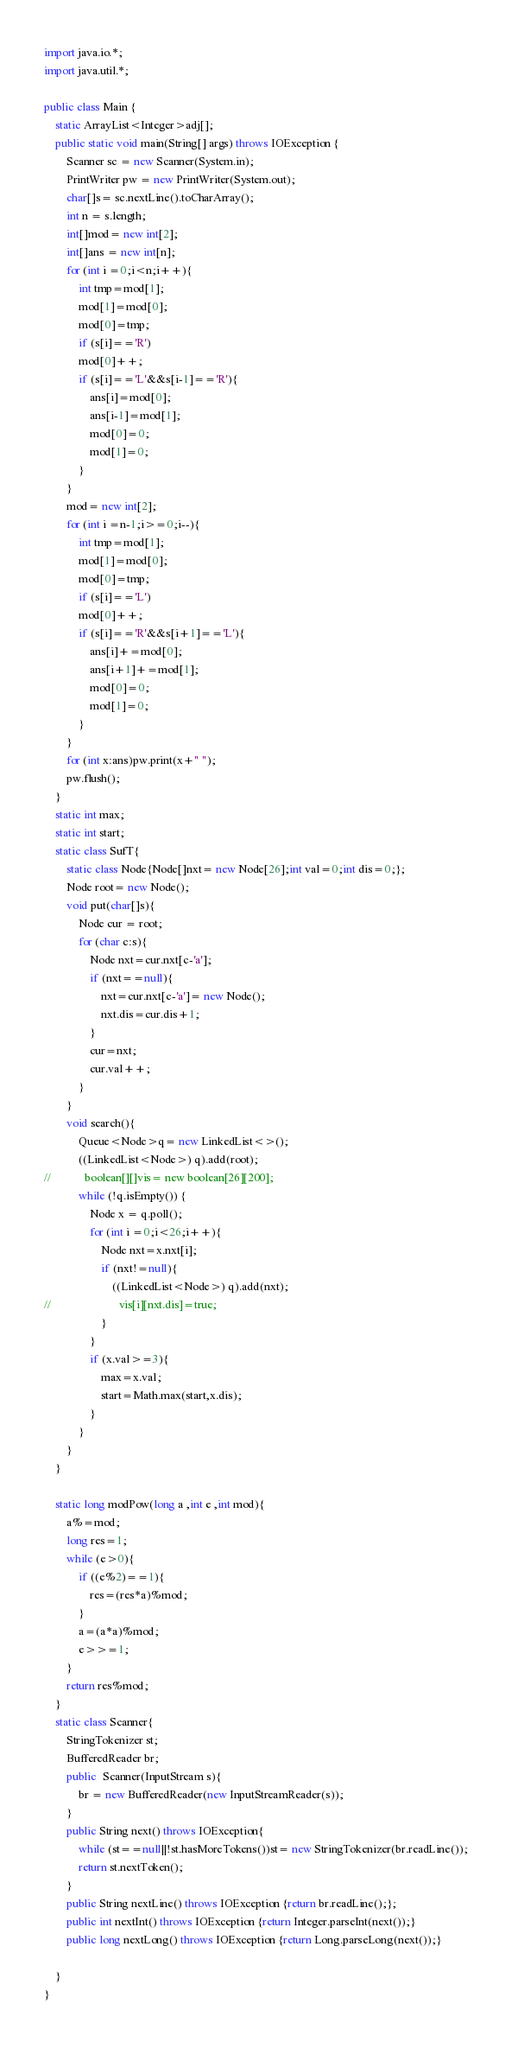Convert code to text. <code><loc_0><loc_0><loc_500><loc_500><_Java_>import java.io.*;
import java.util.*;

public class Main {
    static ArrayList<Integer>adj[];
    public static void main(String[] args) throws IOException {
        Scanner sc = new Scanner(System.in);
        PrintWriter pw = new PrintWriter(System.out);
        char[]s= sc.nextLine().toCharArray();
        int n = s.length;
        int[]mod= new int[2];
        int[]ans = new int[n];
        for (int i =0;i<n;i++){
            int tmp=mod[1];
            mod[1]=mod[0];
            mod[0]=tmp;
            if (s[i]=='R')
            mod[0]++;
            if (s[i]=='L'&&s[i-1]=='R'){
                ans[i]=mod[0];
                ans[i-1]=mod[1];
                mod[0]=0;
                mod[1]=0;
            }
        }
        mod= new int[2];
        for (int i =n-1;i>=0;i--){
            int tmp=mod[1];
            mod[1]=mod[0];
            mod[0]=tmp;
            if (s[i]=='L')
            mod[0]++;
            if (s[i]=='R'&&s[i+1]=='L'){
                ans[i]+=mod[0];
                ans[i+1]+=mod[1];
                mod[0]=0;
                mod[1]=0;
            }
        }
        for (int x:ans)pw.print(x+" ");
        pw.flush();
    }
    static int max;
    static int start;
    static class SufT{
        static class Node{Node[]nxt= new Node[26];int val=0;int dis=0;};
        Node root= new Node();
        void put(char[]s){
            Node cur = root;
            for (char c:s){
                Node nxt=cur.nxt[c-'a'];
                if (nxt==null){
                    nxt=cur.nxt[c-'a']= new Node();
                    nxt.dis=cur.dis+1;
                }
                cur=nxt;
                cur.val++;
            }
        }
        void search(){
            Queue<Node>q= new LinkedList<>();
            ((LinkedList<Node>) q).add(root);
//            boolean[][]vis= new boolean[26][200];
            while (!q.isEmpty()) {
                Node x = q.poll();
                for (int i =0;i<26;i++){
                    Node nxt=x.nxt[i];
                    if (nxt!=null){
                        ((LinkedList<Node>) q).add(nxt);
//                        vis[i][nxt.dis]=true;
                    }
                }
                if (x.val>=3){
                    max=x.val;
                    start=Math.max(start,x.dis);
                }
            }
        }
    }

    static long modPow(long a ,int e ,int mod){
        a%=mod;
        long res=1;
        while (e>0){
            if ((e%2)==1){
                res=(res*a)%mod;
            }
            a=(a*a)%mod;
            e>>=1;
        }
        return res%mod;
    }
    static class Scanner{
        StringTokenizer st;
        BufferedReader br;
        public  Scanner(InputStream s){
            br = new BufferedReader(new InputStreamReader(s));
        }
        public String next() throws IOException{
            while (st==null||!st.hasMoreTokens())st= new StringTokenizer(br.readLine());
            return st.nextToken();
        }
        public String nextLine() throws IOException {return br.readLine();};
        public int nextInt() throws IOException {return Integer.parseInt(next());}
        public long nextLong() throws IOException {return Long.parseLong(next());}

    }
}
</code> 